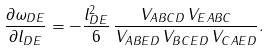<formula> <loc_0><loc_0><loc_500><loc_500>\frac { \partial \omega _ { D E } } { \partial l _ { D E } } = - \frac { l _ { D E } ^ { 2 } } { 6 } \, \frac { V _ { A B C D } \, V _ { E A B C } } { V _ { A B E D } \, V _ { B C E D } \, V _ { C A E D } } .</formula> 